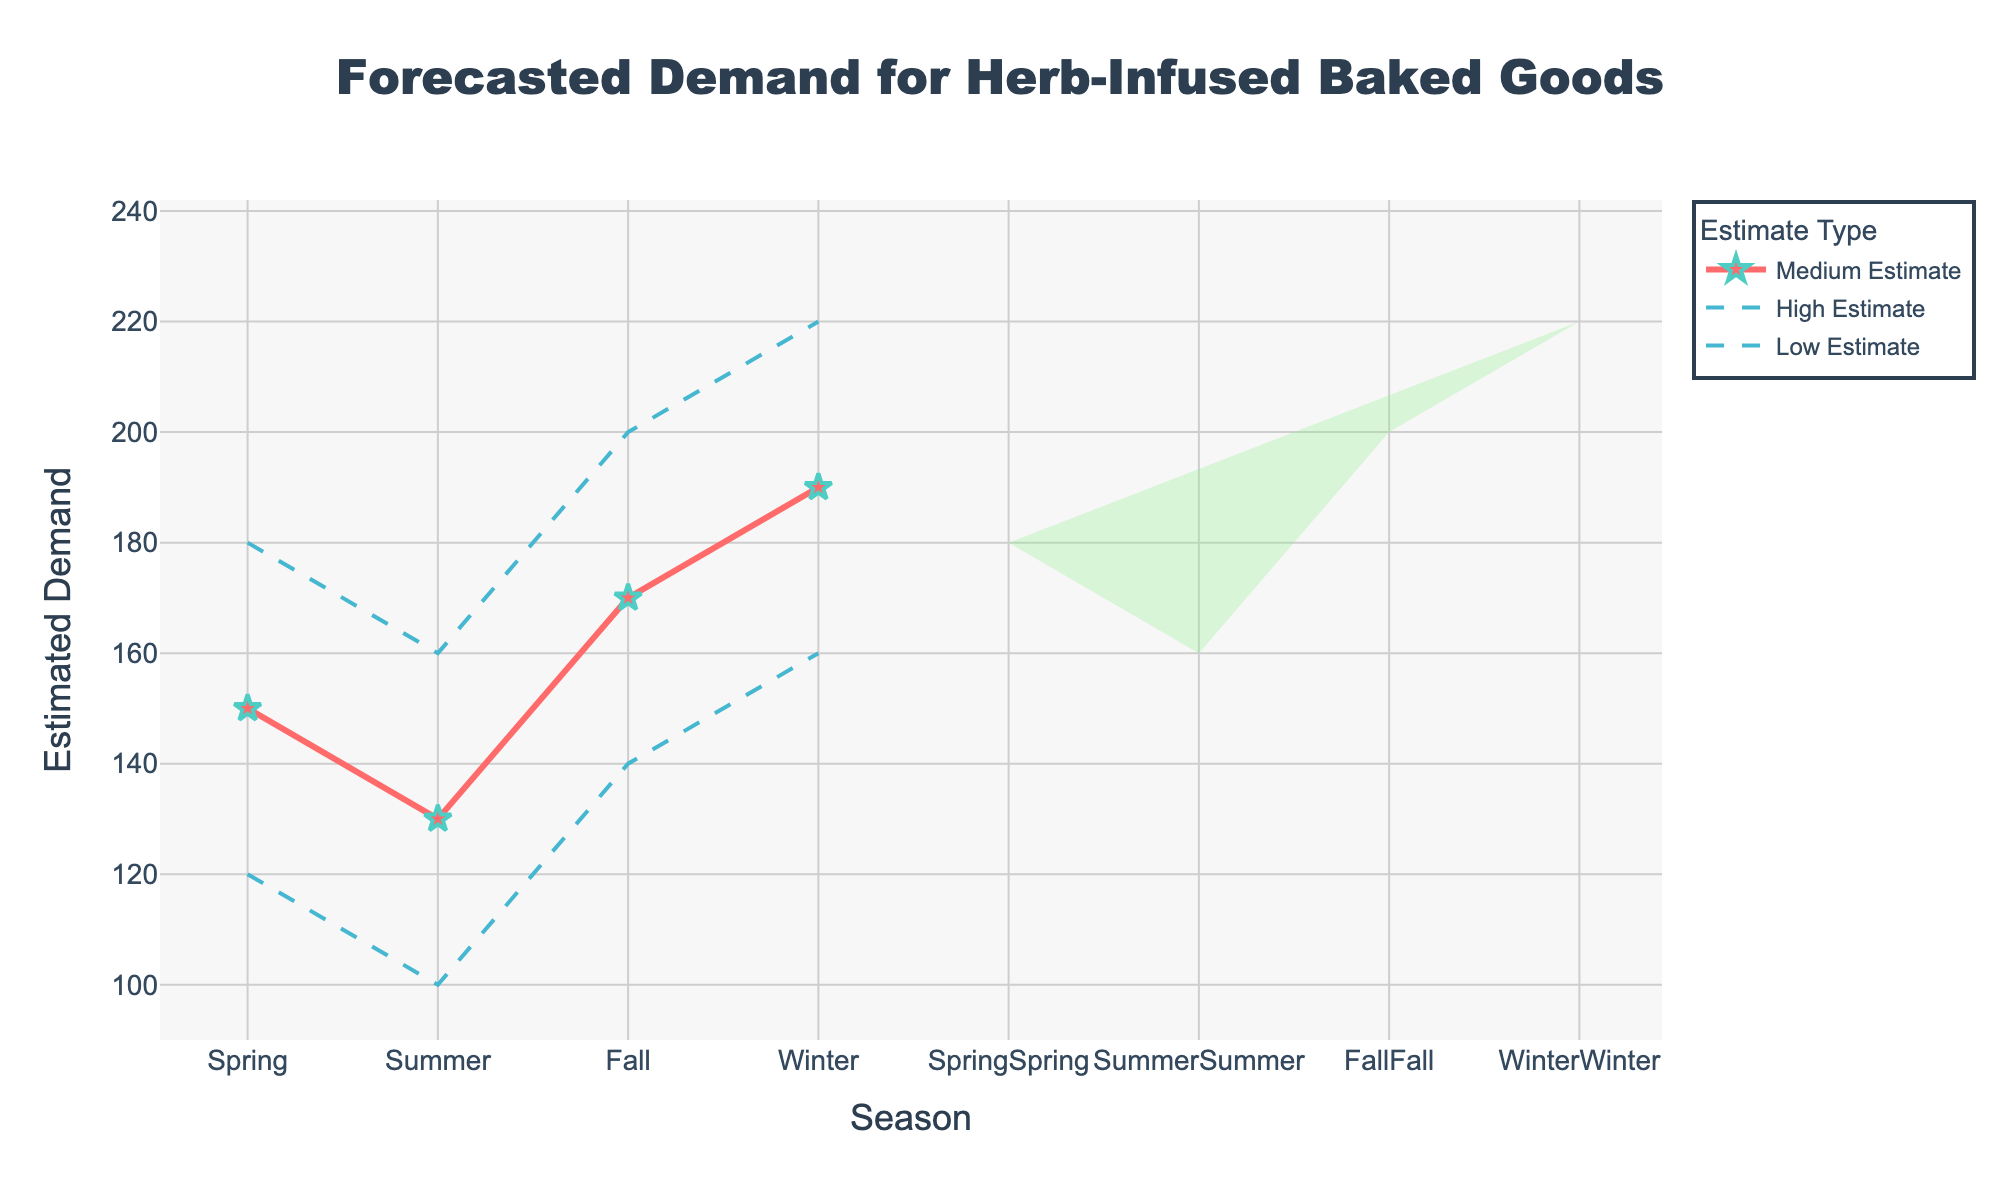what is the title of the chart? The title of the chart is written at the top, often larger and more prominent than the rest of the text
Answer: Forecasted Demand for Herb-Infused Baked Goods What is the estimated demand range in Winter? The estimated demand range in Winter can be found between the low and high estimates for the Winter season in the figure.
Answer: 160 to 220 Which season has the highest high estimate for demand? To identify this, look for the highest value in the series that represents the high estimates across all seasons. Winter has the highest line among the high estimates.
Answer: Winter Compare the medium estimates of Summer and Fall. Which season has a higher demand? Check the medium estimate lines in the chart for Summer and Fall, then compare their values to see which is higher. The medium estimate for Summer is 130, while for Fall, it is 170.
Answer: Fall What is the range difference between high and low estimates for Spring? The range difference is calculated by subtracting the low estimate from the high estimate for Spring. The low estimate for Spring is 120, and the high estimate is 180. Therefore, 180 - 120 = 60.
Answer: 60 In which season is the medium estimate greater than 150? Check the medium estimate values for each season and find where it is greater than 150. The medium estimates are: Spring 150, Summer 130, Fall 170, Winter 190. Only Fall and Winter meet this criterion.
Answer: Fall, Winter Which season has the narrowest forecast range between the low and high estimates? Find the difference between high and low estimates for each season and identify the smallest difference. Spring has a range of 60, Summer 60, Fall 60, Winter 60, so all seasons have the same range.
Answer: All seasons have the same range How does the medium estimate demand in Winter compare to that in Spring? Compare the medium estimate values for Winter and Spring, which are 190 and 150 respectively. Winter has a higher medium estimate than Spring.
Answer: Winter is higher What’s the combined range of the medium estimates for all seasons? Add together the medium estimates for all seasons: Spring, Summer, Fall, and Winter. 150 + 130 + 170 + 190 = 640.
Answer: 640 What's the highest low estimate and in which season does it occur? Identify the highest value in the low estimate series and note the associated season. Winter shows the highest low estimate at 160.
Answer: 160, Winter 